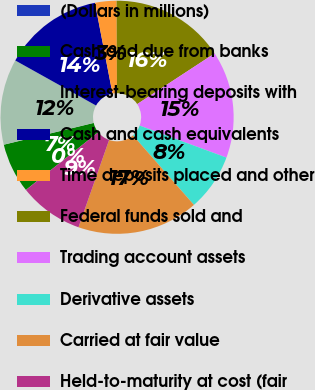Convert chart to OTSL. <chart><loc_0><loc_0><loc_500><loc_500><pie_chart><fcel>(Dollars in millions)<fcel>Cash and due from banks<fcel>Interest-bearing deposits with<fcel>Cash and cash equivalents<fcel>Time deposits placed and other<fcel>Federal funds sold and<fcel>Trading account assets<fcel>Derivative assets<fcel>Carried at fair value<fcel>Held-to-maturity at cost (fair<nl><fcel>0.01%<fcel>6.93%<fcel>11.88%<fcel>13.86%<fcel>2.98%<fcel>15.84%<fcel>14.85%<fcel>7.92%<fcel>16.83%<fcel>8.91%<nl></chart> 